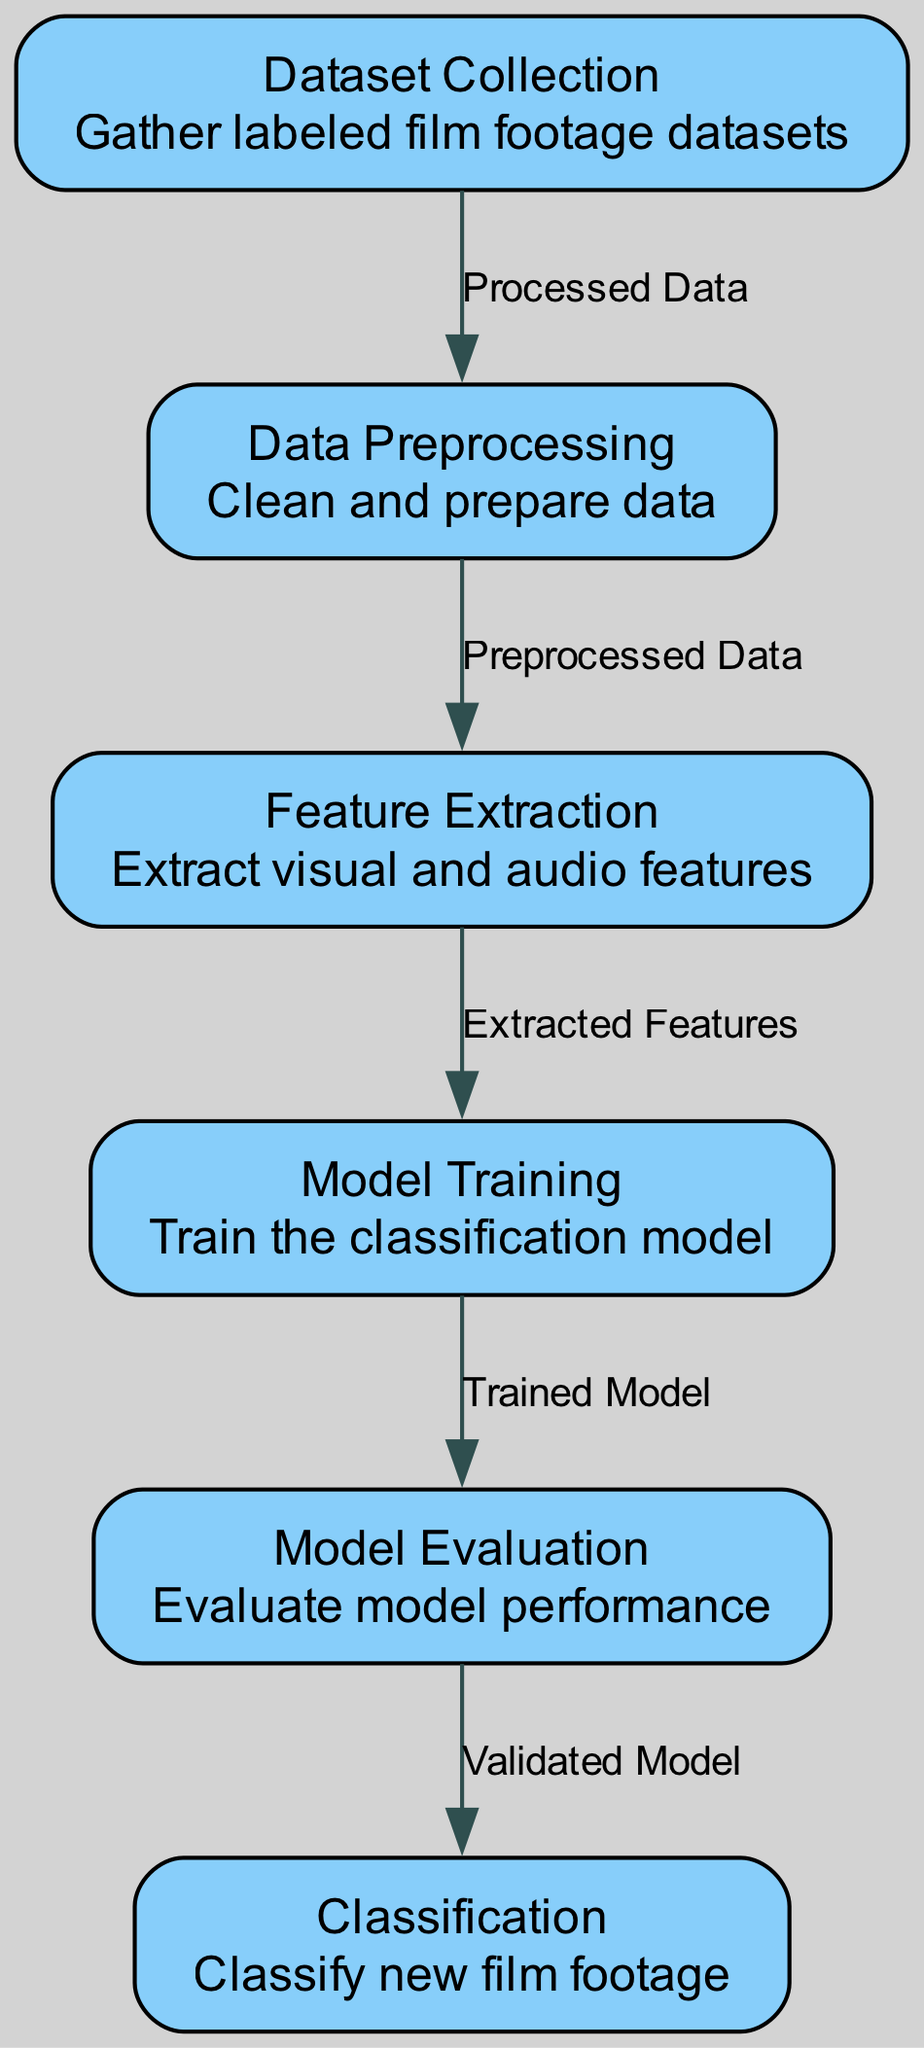What is the first step in the diagram? The first step is "Dataset Collection," which involves gathering labeled film footage datasets before any processing can occur.
Answer: Dataset Collection How many nodes are present in the diagram? By counting each unique part represented in the diagram, we find there are six nodes: Dataset Collection, Data Preprocessing, Feature Extraction, Model Training, Model Evaluation, and Classification.
Answer: Six What is the label of the last node in the diagram? The last node's label is "Classification," which signifies the step where new film footage is classified based on the model developed in prior steps.
Answer: Classification What type of data do we obtain after "Data Preprocessing"? After "Data Preprocessing," we obtain "Preprocessed Data," indicating that the initial datasets have been cleaned and prepared for subsequent analysis.
Answer: Preprocessed Data Which node follows "Feature Extraction" in the process? "Model Training" is the node that follows "Feature Extraction," where the features extracted from film footage are used to train a classification model.
Answer: Model Training What is the relationship between "Model Evaluation" and "Classification"? The relationship shows that the "Classification" step uses a "Validated Model" that has been assessed through "Model Evaluation" to ensure it meets performance standards before classifying new footage.
Answer: Validated Model Which step comes before "Feature Extraction"? The step preceding "Feature Extraction" is "Data Preprocessing," where the raw data is cleaned and prepared to ensure quality input for feature extraction.
Answer: Data Preprocessing What is being extracted in the "Feature Extraction" node? In the "Feature Extraction" node, "visual and audio features" are extracted, which are essential components for the model to learn from the film footage.
Answer: Visual and audio features What is the output of the "Model Training" node? The output of the "Model Training" node is a "Trained Model," which signifies that the model has been trained on the prepared features extracted from the film footage.
Answer: Trained Model 